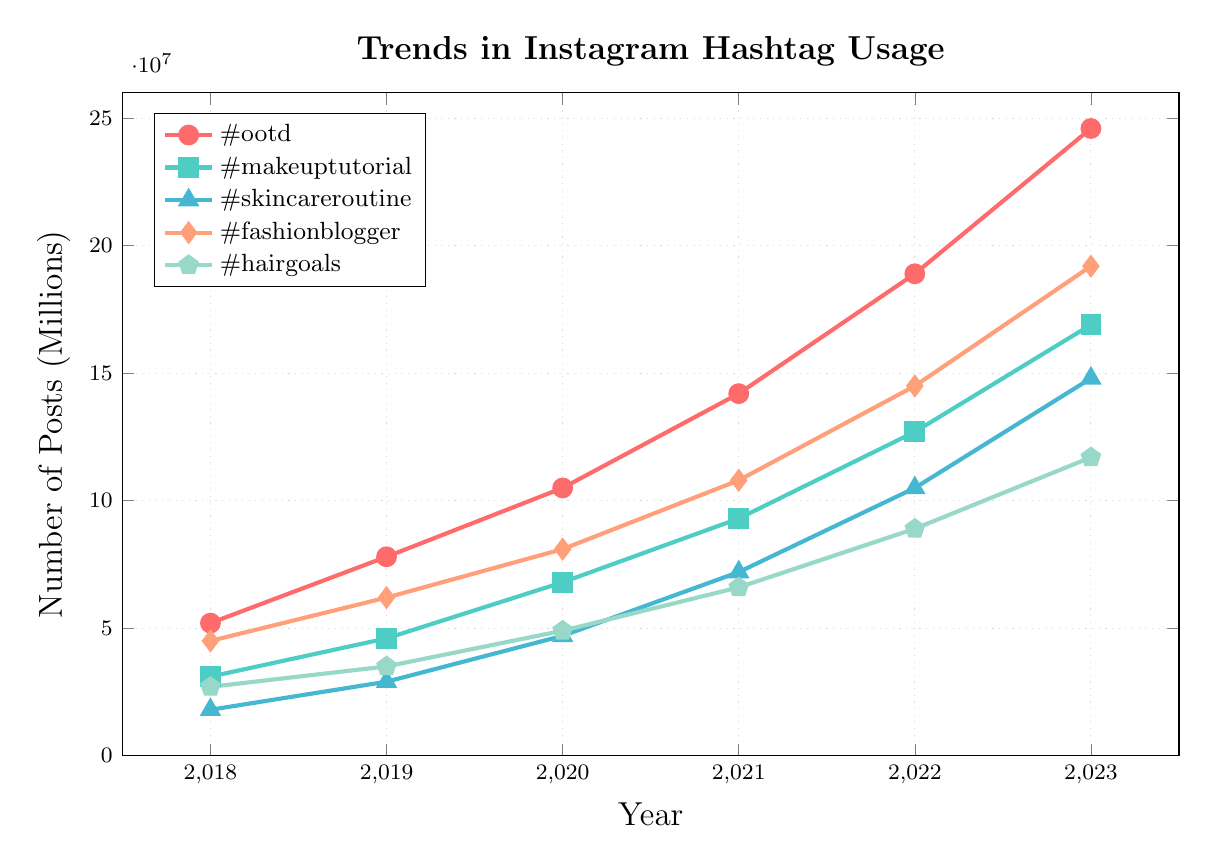what's the trend in the number of posts with the hashtag #ootd from 2018 to 2023? The number of posts with the hashtag #ootd consistently increases each year. Starting at 5.2 million in 2018, it rises each year to 24.6 million in 2023. This indicates a strong upward trend.
Answer: Upward trend Which hashtag had the highest number of posts in 2022? By comparing the data points for 2022, the hashtag #ootd has the highest number of posts at 18.9 million.
Answer: #ootd What is the total number of posts for the hashtag #fashionblogger from 2018 to 2023? Add up the number of posts for each year for the hashtag #fashionblogger: 4.5 million in 2018, 6.2 million in 2019, 8.1 million in 2020, 10.8 million in 2021, 14.5 million in 2022, and 19.2 million in 2023. The total is 63.3 million.
Answer: 63.3 million Which hashtag shows the most significant increase in the number of posts from 2018 to 2023? Calculate the difference in the number of posts from 2018 to 2023 for each hashtag: 
#ootd: 24.6M - 5.2M = 19.4M,
#makeuptutorial: 16.9M - 3.1M = 13.8M,
#skincareroutine: 14.8M - 1.8M = 13M,
#fashionblogger: 19.2M - 4.5M = 14.7M,
#hairgoals: 11.7M - 2.7M = 9M.
The hashtag #ootd shows the most significant increase with a 19.4 million rise.
Answer: #ootd What is the average number of posts for the hashtag #hairgoals over the six years? Add the number of posts for #hairgoals for each year and divide by 6. (2.7M + 3.5M + 4.9M + 6.6M + 8.9M + 11.7M) / 6 = 38.3M / 6 = 6.38M.
Answer: 6.38 million Which hashtag had the slowest growth rate from 2018 to 2023? Determine the growth rate for each hashtag by calculating the percentage increase from 2018 to 2023 and find the lowest one:
#ootd: (24.6M - 5.2M) / 5.2M * 100 = 373%,
#makeuptutorial: (16.9M - 3.1M) / 3.1M * 100 = 445%,
#skincareroutine: (14.8M - 1.8M) / 1.8M * 100 = 722%,
#fashionblogger: (19.2M - 4.5M) / 4.5M * 100 = 326%,
#hairgoals: (11.7M - 2.7M) / 2.7M * 100 = 333%.
The hashtag #fashionblogger has the slowest growth rate at 326%.
Answer: #fashionblogger Between 2020 and 2021, which hashtag experienced the largest increase in the number of posts? Calculate the increase for each hashtag between 2020 and 2021:
#ootd: 14.2M - 10.5M = 3.7M,
#makeuptutorial: 9.3M - 6.8M = 2.5M,
#skincareroutine: 7.2M - 4.7M = 2.5M,
#fashionblogger: 10.8M - 8.1M = 2.7M,
#hairgoals: 6.6M - 4.9M = 1.7M.
The hashtag #ootd experienced the largest increase with 3.7 million additional posts.
Answer: #ootd What is the combined total number of posts for the hashtags #makeuptutorial and #skincareroutine in 2021? Add the number of posts for #makeuptutorial and #skincareroutine for the year 2021: 9.3 million for #makeuptutorial plus 7.2 million for #skincareroutine equals 16.5 million.
Answer: 16.5 million 